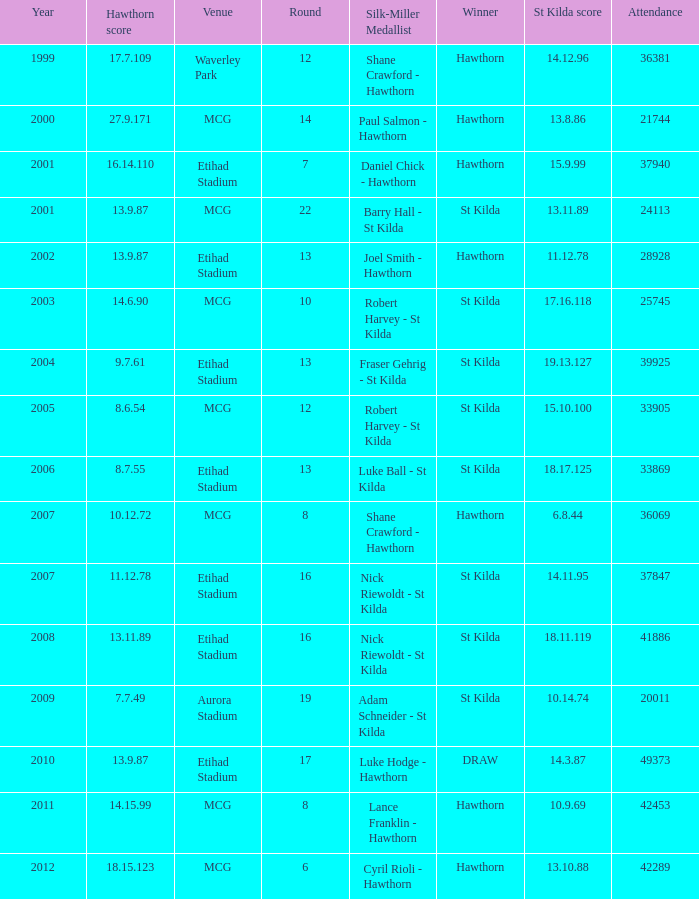What the listed in round when the hawthorn score is 17.7.109? 12.0. 